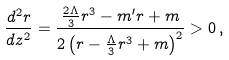<formula> <loc_0><loc_0><loc_500><loc_500>\frac { d ^ { 2 } r } { d z ^ { 2 } } = \frac { \frac { 2 \Lambda } { 3 } r ^ { 3 } - m ^ { \prime } r + m } { 2 \left ( r - \frac { \Lambda } { 3 } r ^ { 3 } + m \right ) ^ { 2 } } > 0 \, ,</formula> 